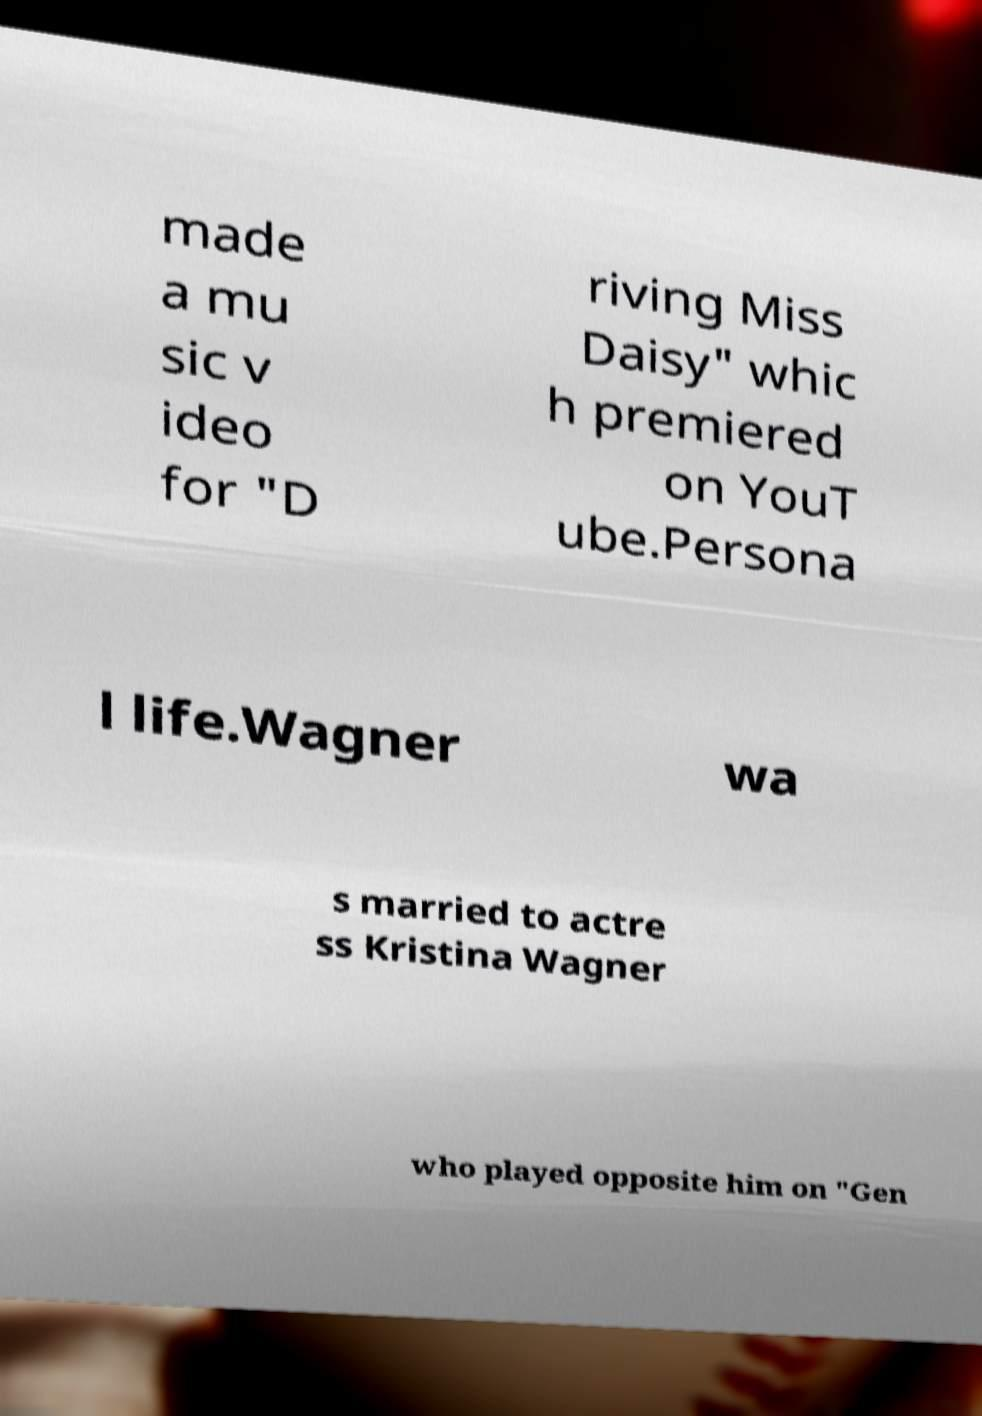For documentation purposes, I need the text within this image transcribed. Could you provide that? made a mu sic v ideo for "D riving Miss Daisy" whic h premiered on YouT ube.Persona l life.Wagner wa s married to actre ss Kristina Wagner who played opposite him on "Gen 